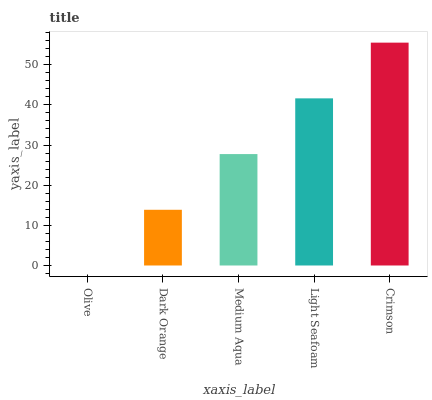Is Olive the minimum?
Answer yes or no. Yes. Is Crimson the maximum?
Answer yes or no. Yes. Is Dark Orange the minimum?
Answer yes or no. No. Is Dark Orange the maximum?
Answer yes or no. No. Is Dark Orange greater than Olive?
Answer yes or no. Yes. Is Olive less than Dark Orange?
Answer yes or no. Yes. Is Olive greater than Dark Orange?
Answer yes or no. No. Is Dark Orange less than Olive?
Answer yes or no. No. Is Medium Aqua the high median?
Answer yes or no. Yes. Is Medium Aqua the low median?
Answer yes or no. Yes. Is Light Seafoam the high median?
Answer yes or no. No. Is Olive the low median?
Answer yes or no. No. 